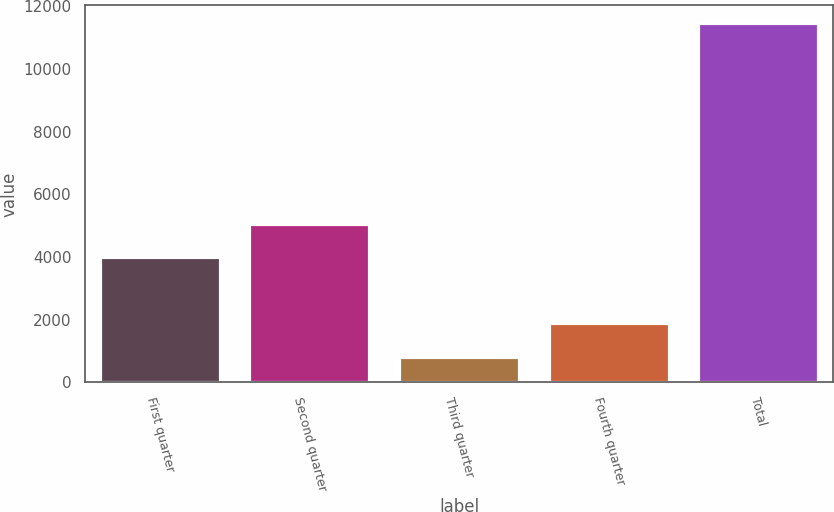<chart> <loc_0><loc_0><loc_500><loc_500><bar_chart><fcel>First quarter<fcel>Second quarter<fcel>Third quarter<fcel>Fourth quarter<fcel>Total<nl><fcel>4000<fcel>5063.1<fcel>827<fcel>1890.1<fcel>11458<nl></chart> 